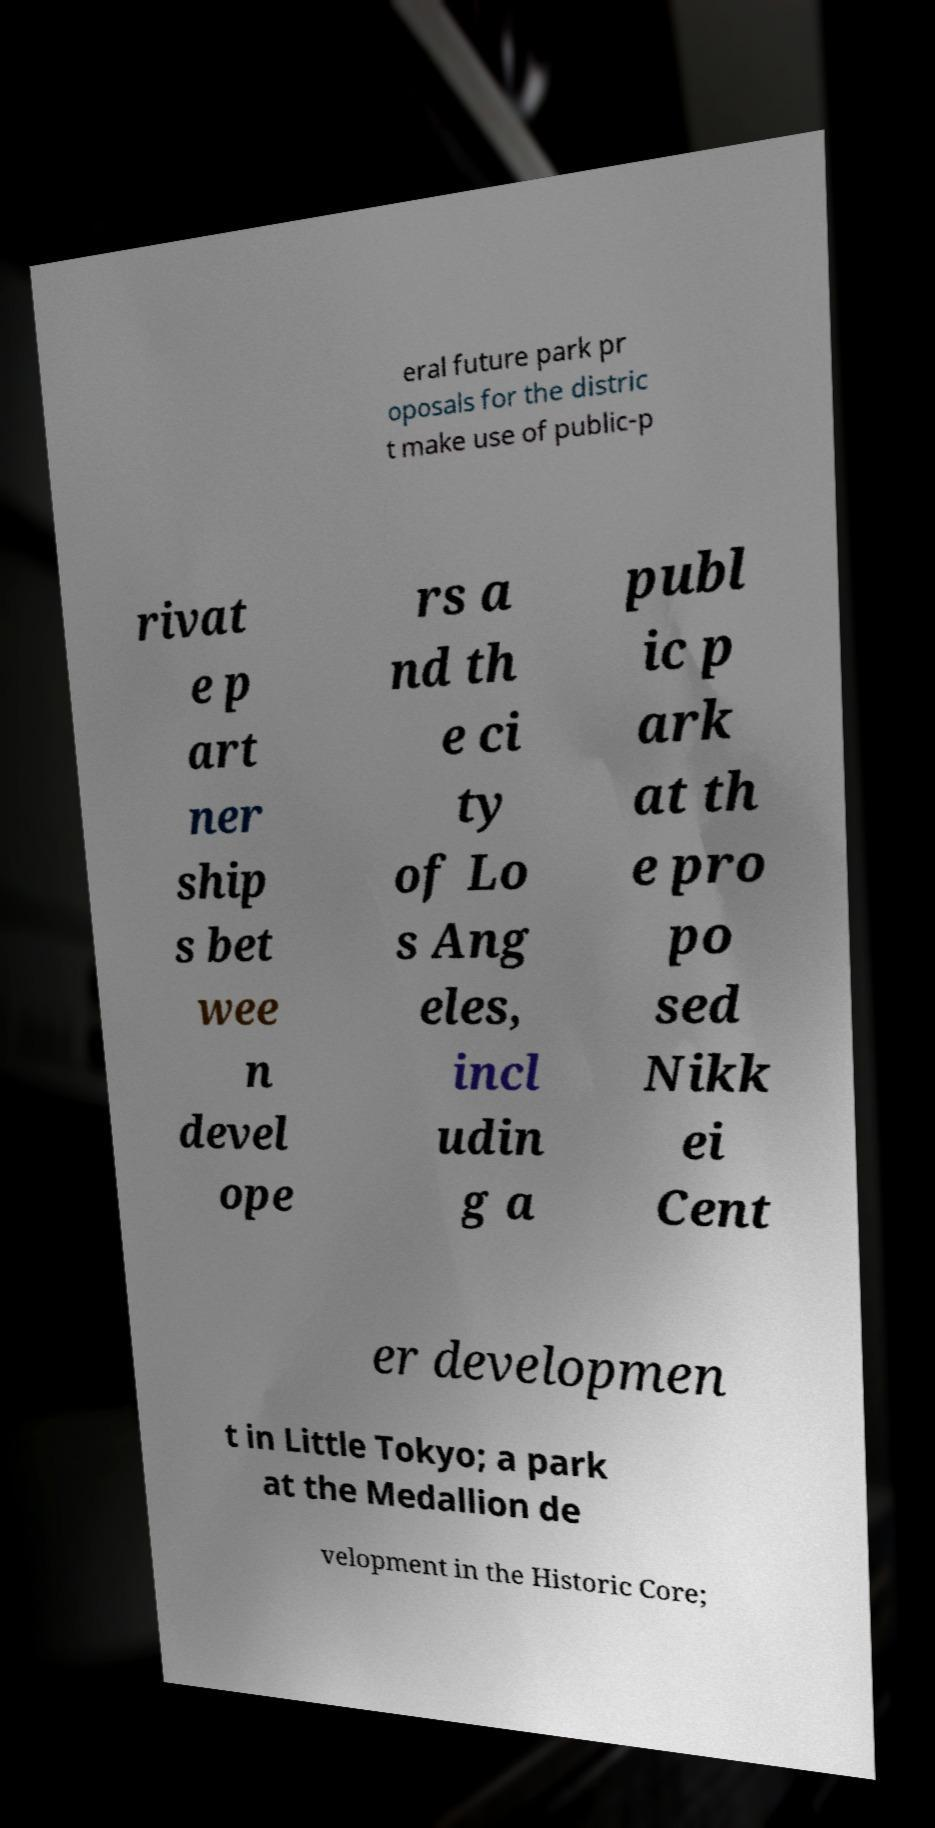Could you extract and type out the text from this image? eral future park pr oposals for the distric t make use of public-p rivat e p art ner ship s bet wee n devel ope rs a nd th e ci ty of Lo s Ang eles, incl udin g a publ ic p ark at th e pro po sed Nikk ei Cent er developmen t in Little Tokyo; a park at the Medallion de velopment in the Historic Core; 